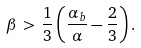Convert formula to latex. <formula><loc_0><loc_0><loc_500><loc_500>\beta \, > \, \frac { 1 } { 3 } \left ( \frac { \alpha _ { b } } { \alpha } - \frac { 2 } { 3 } \right ) .</formula> 